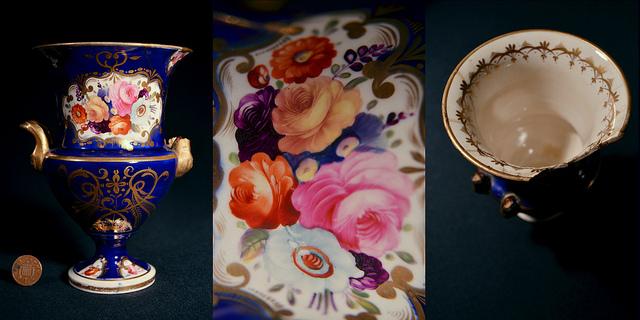How many flowers are pictured?
Concise answer only. 10. IS the vase empty?
Write a very short answer. Yes. Is this vase damaged?
Give a very brief answer. Yes. Is the flower real?
Give a very brief answer. No. What color is the vase?
Give a very brief answer. Blue. 